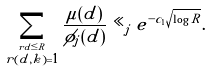Convert formula to latex. <formula><loc_0><loc_0><loc_500><loc_500>\sum _ { \stackrel { r d \leq R } { r ( d , k ) = 1 } } \frac { \mu ( d ) } { \phi _ { j } ( d ) } \ll _ { j } e ^ { - c _ { 1 } \sqrt { \log R } } .</formula> 